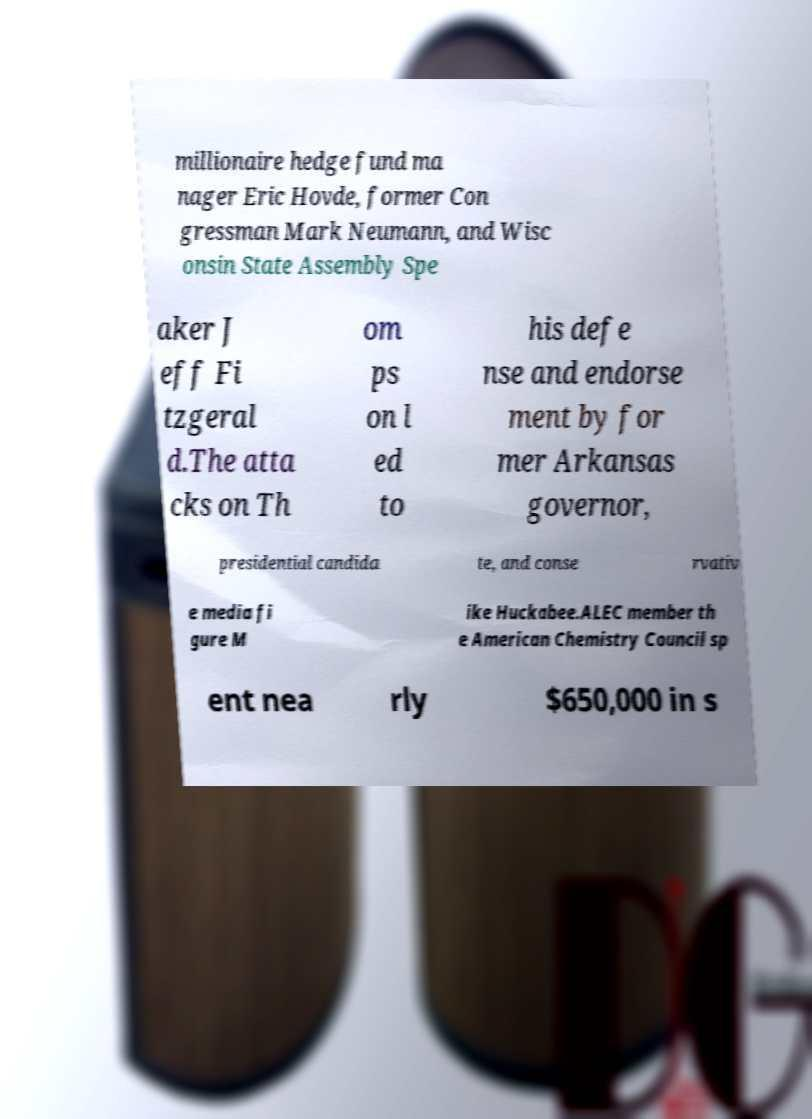Could you assist in decoding the text presented in this image and type it out clearly? millionaire hedge fund ma nager Eric Hovde, former Con gressman Mark Neumann, and Wisc onsin State Assembly Spe aker J eff Fi tzgeral d.The atta cks on Th om ps on l ed to his defe nse and endorse ment by for mer Arkansas governor, presidential candida te, and conse rvativ e media fi gure M ike Huckabee.ALEC member th e American Chemistry Council sp ent nea rly $650,000 in s 